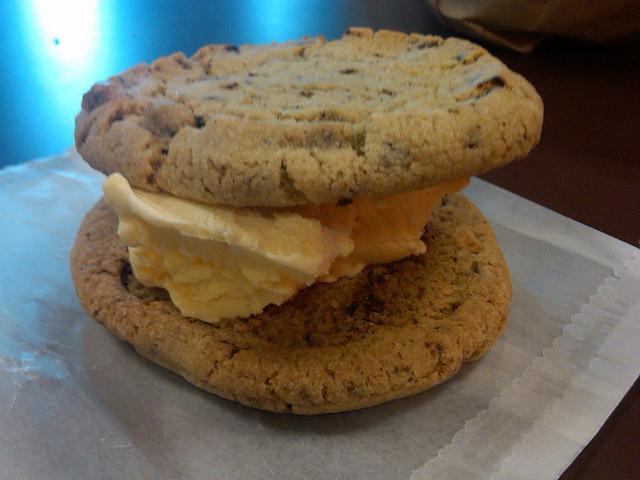Is this a sandwich?
Keep it brief. Yes. What is in between the cookies?
Write a very short answer. Ice cream. What is inside the bun?
Keep it brief. Ice cream. Has the sandwich been cut?
Be succinct. No. Are those chocolate chip cookies?
Answer briefly. Yes. 